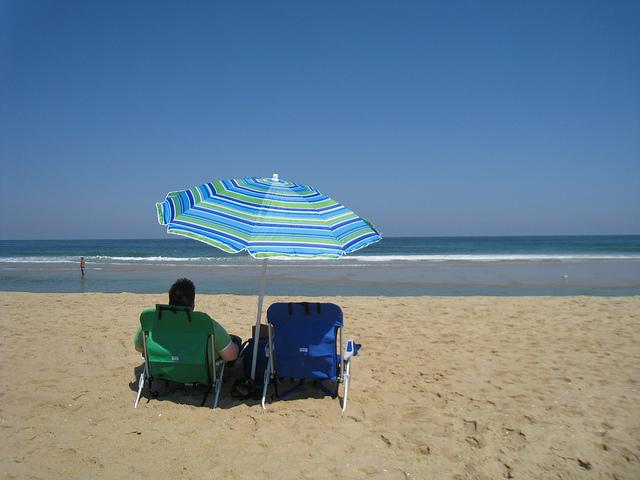Judging by the shadows, is the sun directly overhead?
Answer briefly. Yes. What color is the chair on the sand?
Short answer required. Blue. Is it winter?
Be succinct. No. What pattern is on the umbrella?
Write a very short answer. Stripes. Are any people visible?
Quick response, please. Yes. What is the umbrella made from?
Give a very brief answer. Polyester. How many people are on the beach?
Short answer required. 2. Is anyone sitting in the chairs?
Quick response, please. Yes. Are the umbrellas made of straw?
Give a very brief answer. No. 